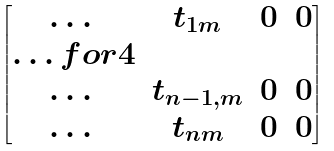Convert formula to latex. <formula><loc_0><loc_0><loc_500><loc_500>\begin{bmatrix} \dots & t _ { 1 m } & 0 & 0 \\ \hdots f o r { 4 } \\ \dots & t _ { n - 1 , m } & 0 & 0 \\ \dots & t _ { n m } & 0 & 0 \end{bmatrix}</formula> 